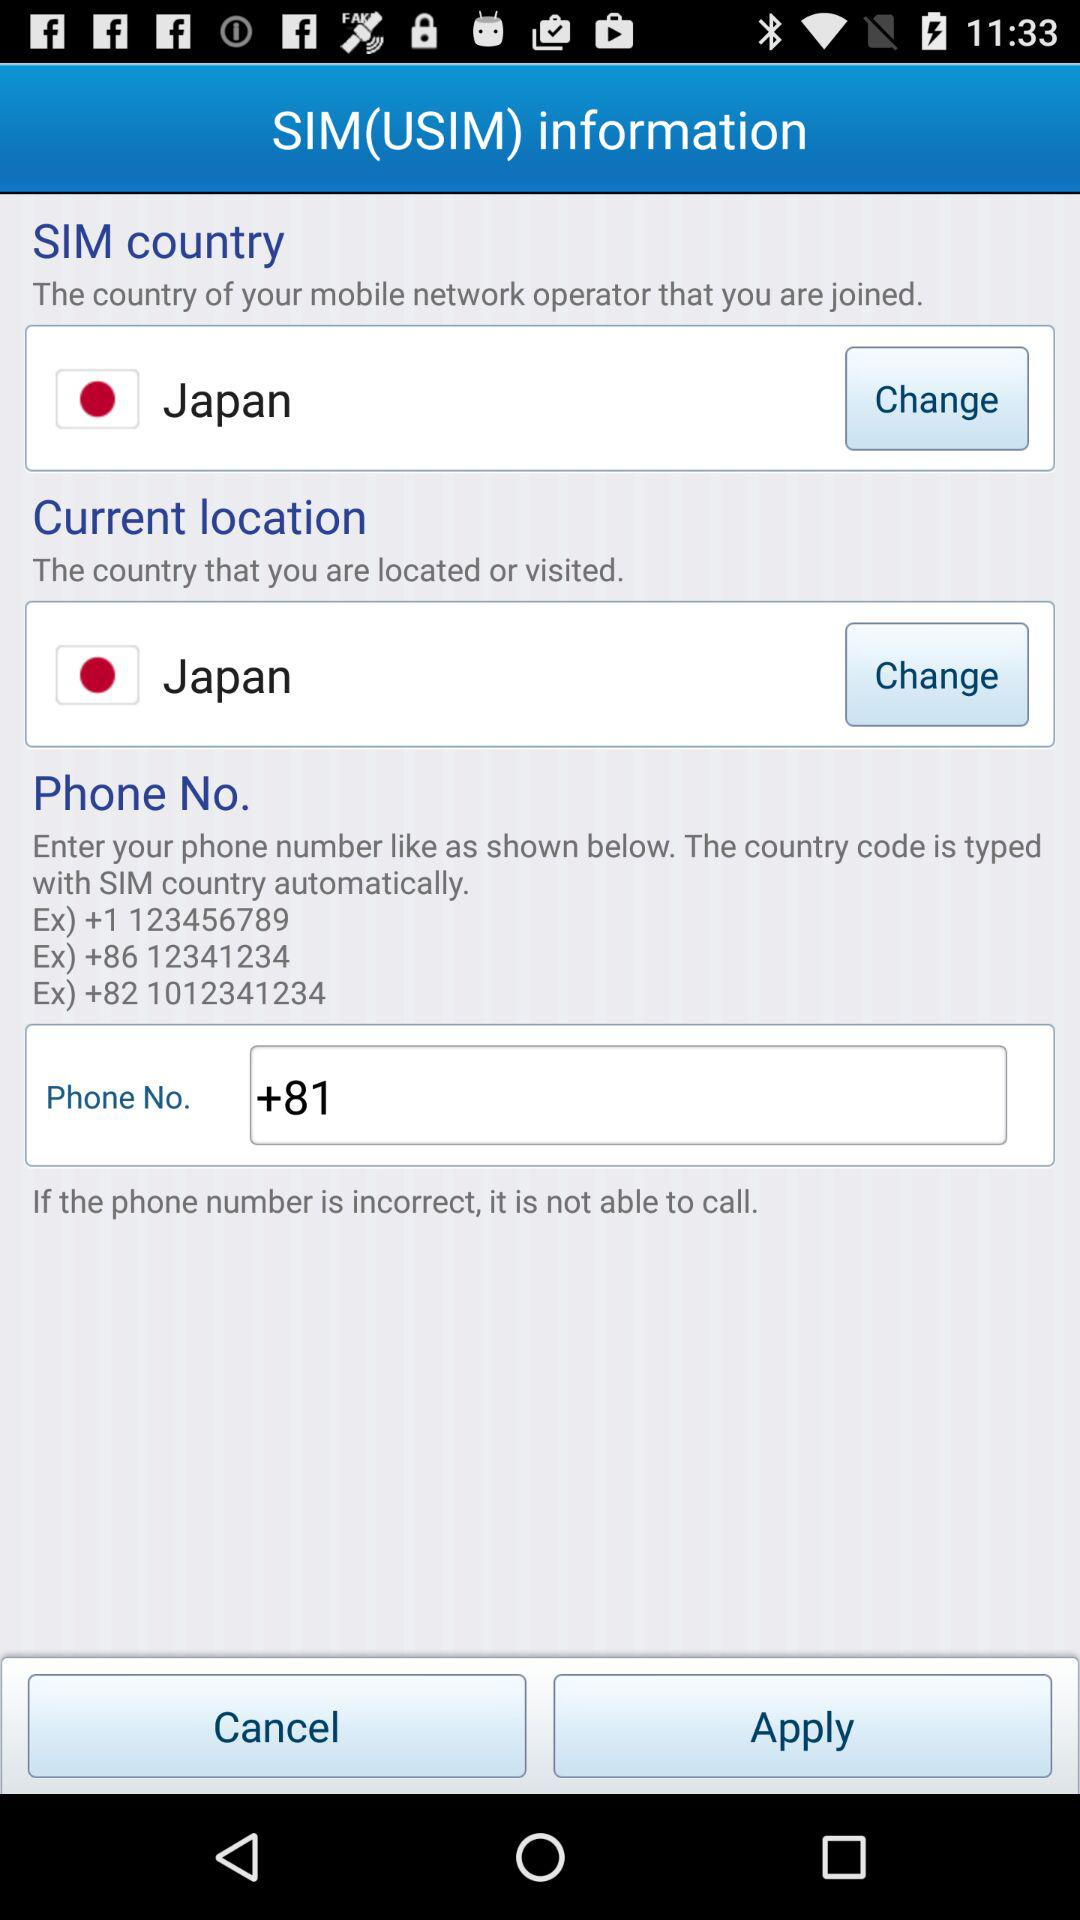What is the selected current location? The selected current location is Japan. 